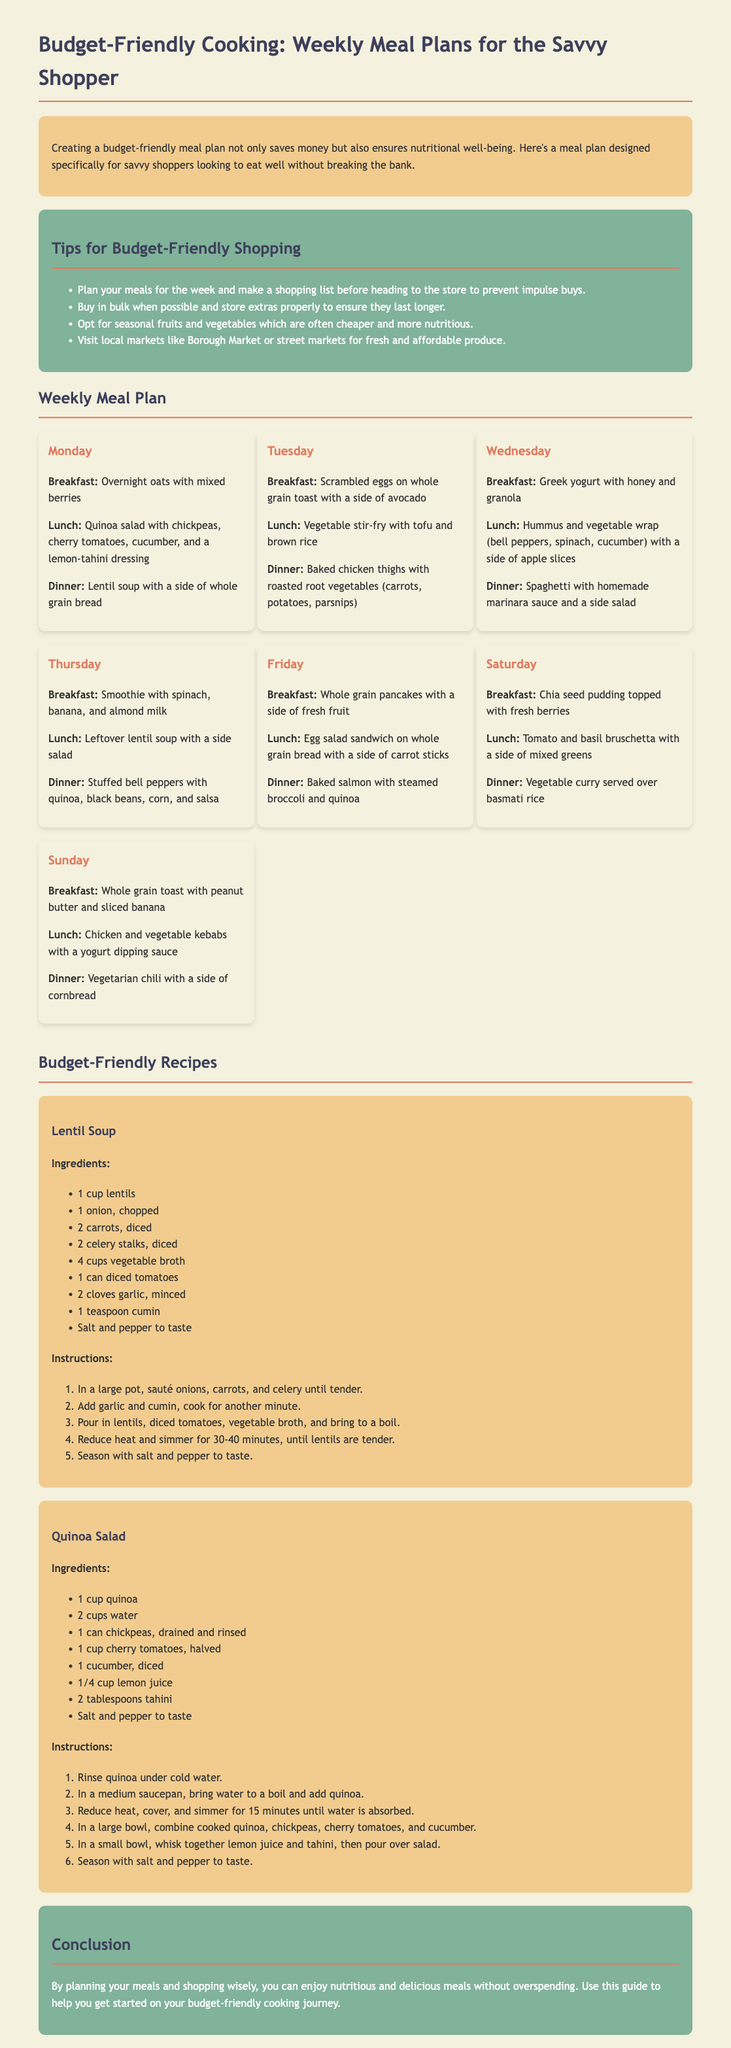What is the title of the document? The title of the document is prominently displayed at the top and describes the overall theme of the content.
Answer: Budget-Friendly Cooking: Weekly Meal Plans for the Savvy Shopper What day is baked chicken thigh served? The document lists specific meals by day, and Tuesday corresponds to the baked chicken thigh meal.
Answer: Tuesday How many cups of vegetable broth are needed for the lentil soup? The recipe section provides exact measurements for ingredients for each dish, and the amount needed for vegetable broth is given among these.
Answer: 4 cups What type of toast is served with scrambled eggs? The breakfast for Tuesday specifies the type of toast served, clearly indicating the bread choice.
Answer: Whole grain Which fruit is suggested for the smoothie on Thursday? The breakfast for Thursday lists the ingredients, indicating the type of fruit included.
Answer: Banana What is the cooking time for the lentil soup? The recipe outlines the process, including the time it takes for the lentils to become tender.
Answer: 30-40 minutes What ingredient is used to dress the quinoa salad? The ingredients for the quinoa salad include a specific dressing component, explaining how the salad is flavored.
Answer: Lemon juice and tahini What is a tip for budget-friendly shopping mentioned in the document? The tips section provides advice on shopping to save money, and one piece of advice is included in the list.
Answer: Plan your meals for the week 